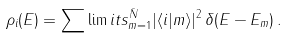<formula> <loc_0><loc_0><loc_500><loc_500>\rho _ { i } ( E ) = \sum \lim i t s _ { m = 1 } ^ { \bar { N } } | \langle i | m \rangle | ^ { 2 } \, \delta ( E - E _ { m } ) \, .</formula> 